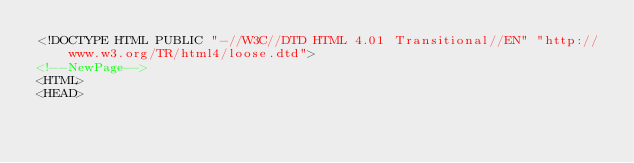<code> <loc_0><loc_0><loc_500><loc_500><_HTML_><!DOCTYPE HTML PUBLIC "-//W3C//DTD HTML 4.01 Transitional//EN" "http://www.w3.org/TR/html4/loose.dtd">
<!--NewPage-->
<HTML>
<HEAD></code> 